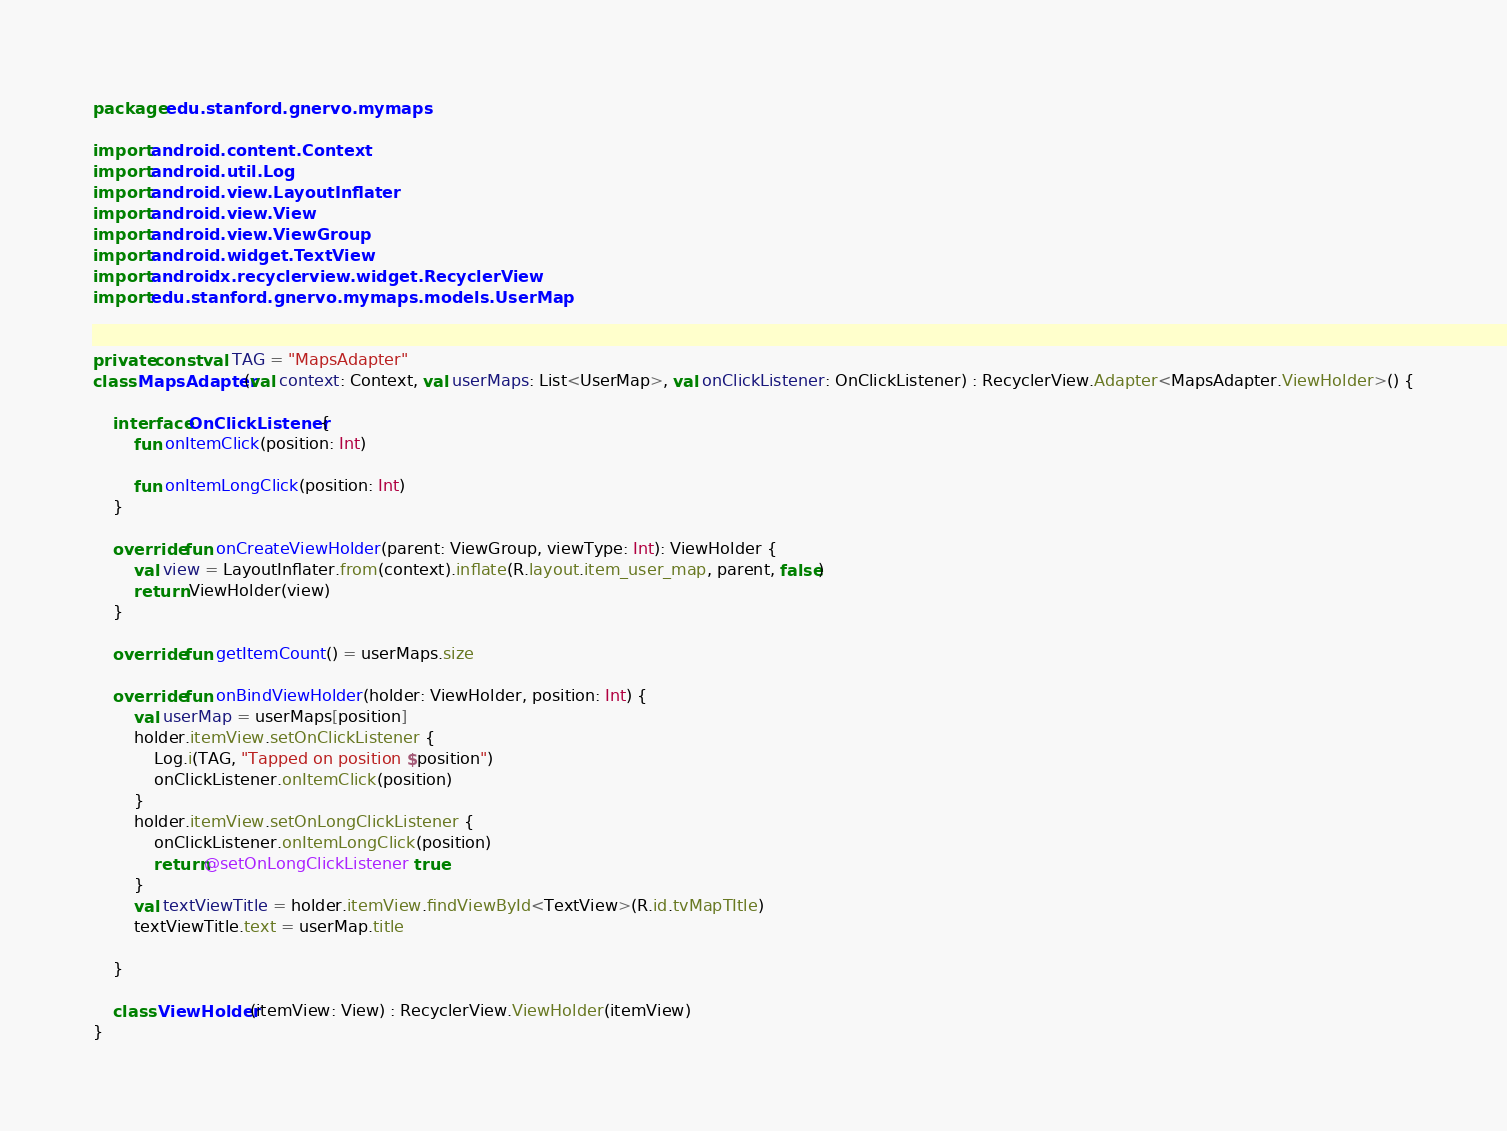Convert code to text. <code><loc_0><loc_0><loc_500><loc_500><_Kotlin_>package edu.stanford.gnervo.mymaps

import android.content.Context
import android.util.Log
import android.view.LayoutInflater
import android.view.View
import android.view.ViewGroup
import android.widget.TextView
import androidx.recyclerview.widget.RecyclerView
import edu.stanford.gnervo.mymaps.models.UserMap


private const val TAG = "MapsAdapter"
class MapsAdapter(val context: Context, val userMaps: List<UserMap>, val onClickListener: OnClickListener) : RecyclerView.Adapter<MapsAdapter.ViewHolder>() {

    interface OnClickListener {
        fun onItemClick(position: Int)

        fun onItemLongClick(position: Int)
    }

    override fun onCreateViewHolder(parent: ViewGroup, viewType: Int): ViewHolder {
        val view = LayoutInflater.from(context).inflate(R.layout.item_user_map, parent, false)
        return ViewHolder(view)
    }

    override fun getItemCount() = userMaps.size

    override fun onBindViewHolder(holder: ViewHolder, position: Int) {
        val userMap = userMaps[position]
        holder.itemView.setOnClickListener {
            Log.i(TAG, "Tapped on position $position")
            onClickListener.onItemClick(position)
        }
        holder.itemView.setOnLongClickListener {
            onClickListener.onItemLongClick(position)
            return@setOnLongClickListener true
        }
        val textViewTitle = holder.itemView.findViewById<TextView>(R.id.tvMapTItle)
        textViewTitle.text = userMap.title

    }

    class ViewHolder(itemView: View) : RecyclerView.ViewHolder(itemView)
}</code> 